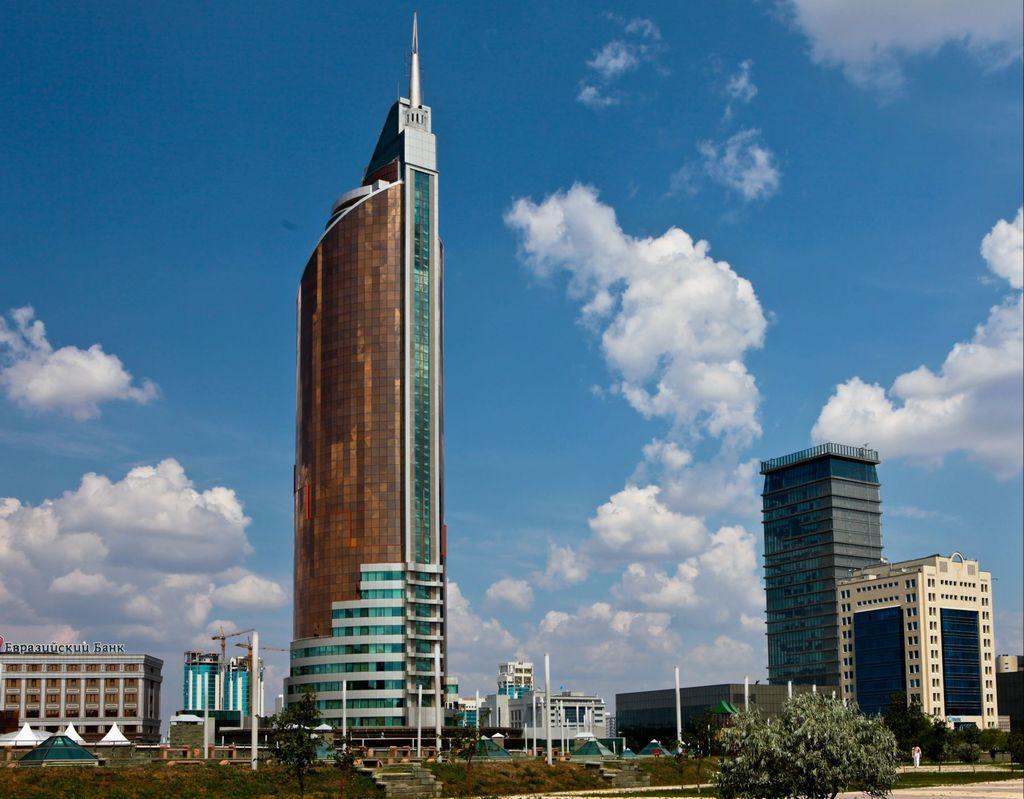In one or two sentences, can you explain what this image depicts? As we can see in the image, there are few buildings. On the top there is sky and clouds. In the front there is a tree. 